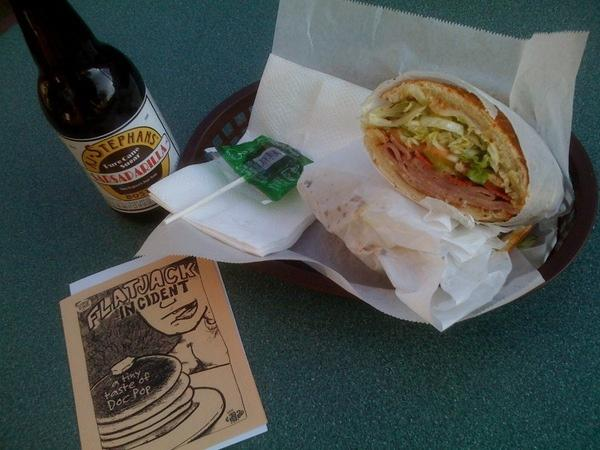This beverage tastes similar to what other beverage? beer 